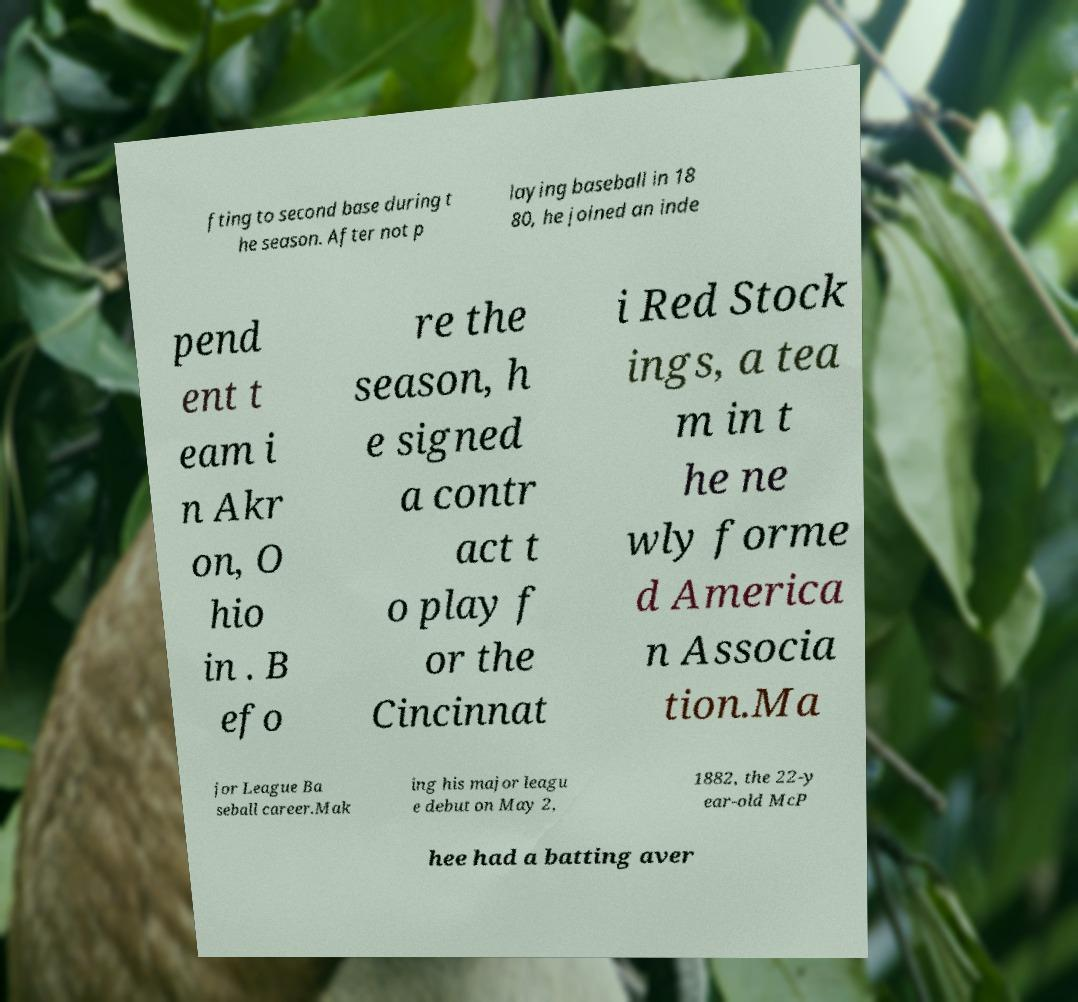Please read and relay the text visible in this image. What does it say? fting to second base during t he season. After not p laying baseball in 18 80, he joined an inde pend ent t eam i n Akr on, O hio in . B efo re the season, h e signed a contr act t o play f or the Cincinnat i Red Stock ings, a tea m in t he ne wly forme d America n Associa tion.Ma jor League Ba seball career.Mak ing his major leagu e debut on May 2, 1882, the 22-y ear-old McP hee had a batting aver 